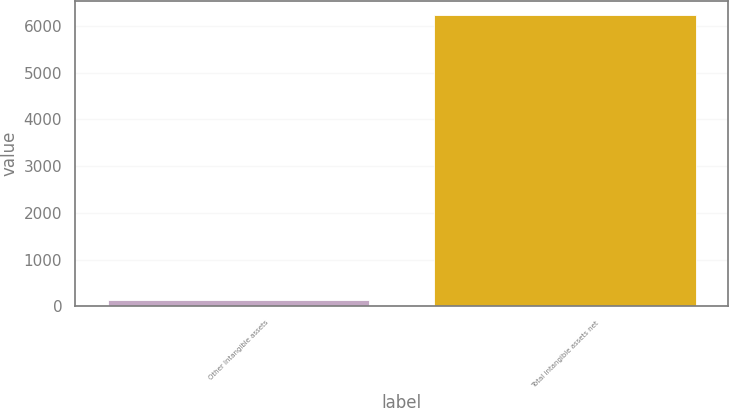<chart> <loc_0><loc_0><loc_500><loc_500><bar_chart><fcel>Other Intangible assets<fcel>Total intangible assets net<nl><fcel>135<fcel>6221<nl></chart> 